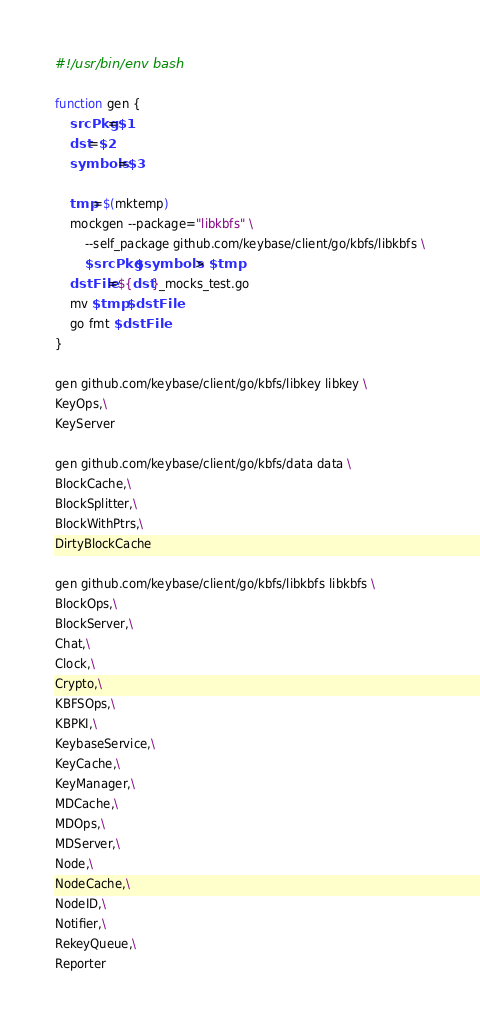Convert code to text. <code><loc_0><loc_0><loc_500><loc_500><_Bash_>#!/usr/bin/env bash

function gen {
    srcPkg=$1
    dst=$2
    symbols=$3

    tmp=$(mktemp)
    mockgen --package="libkbfs" \
        --self_package github.com/keybase/client/go/kbfs/libkbfs \
        $srcPkg $symbols > $tmp
    dstFile=${dst}_mocks_test.go
    mv $tmp $dstFile
    go fmt $dstFile
}

gen github.com/keybase/client/go/kbfs/libkey libkey \
KeyOps,\
KeyServer

gen github.com/keybase/client/go/kbfs/data data \
BlockCache,\
BlockSplitter,\
BlockWithPtrs,\
DirtyBlockCache

gen github.com/keybase/client/go/kbfs/libkbfs libkbfs \
BlockOps,\
BlockServer,\
Chat,\
Clock,\
Crypto,\
KBFSOps,\
KBPKI,\
KeybaseService,\
KeyCache,\
KeyManager,\
MDCache,\
MDOps,\
MDServer,\
Node,\
NodeCache,\
NodeID,\
Notifier,\
RekeyQueue,\
Reporter
</code> 